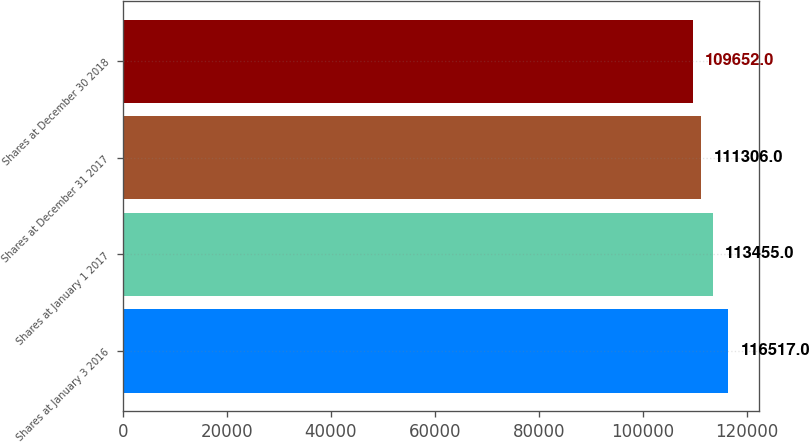Convert chart to OTSL. <chart><loc_0><loc_0><loc_500><loc_500><bar_chart><fcel>Shares at January 3 2016<fcel>Shares at January 1 2017<fcel>Shares at December 31 2017<fcel>Shares at December 30 2018<nl><fcel>116517<fcel>113455<fcel>111306<fcel>109652<nl></chart> 